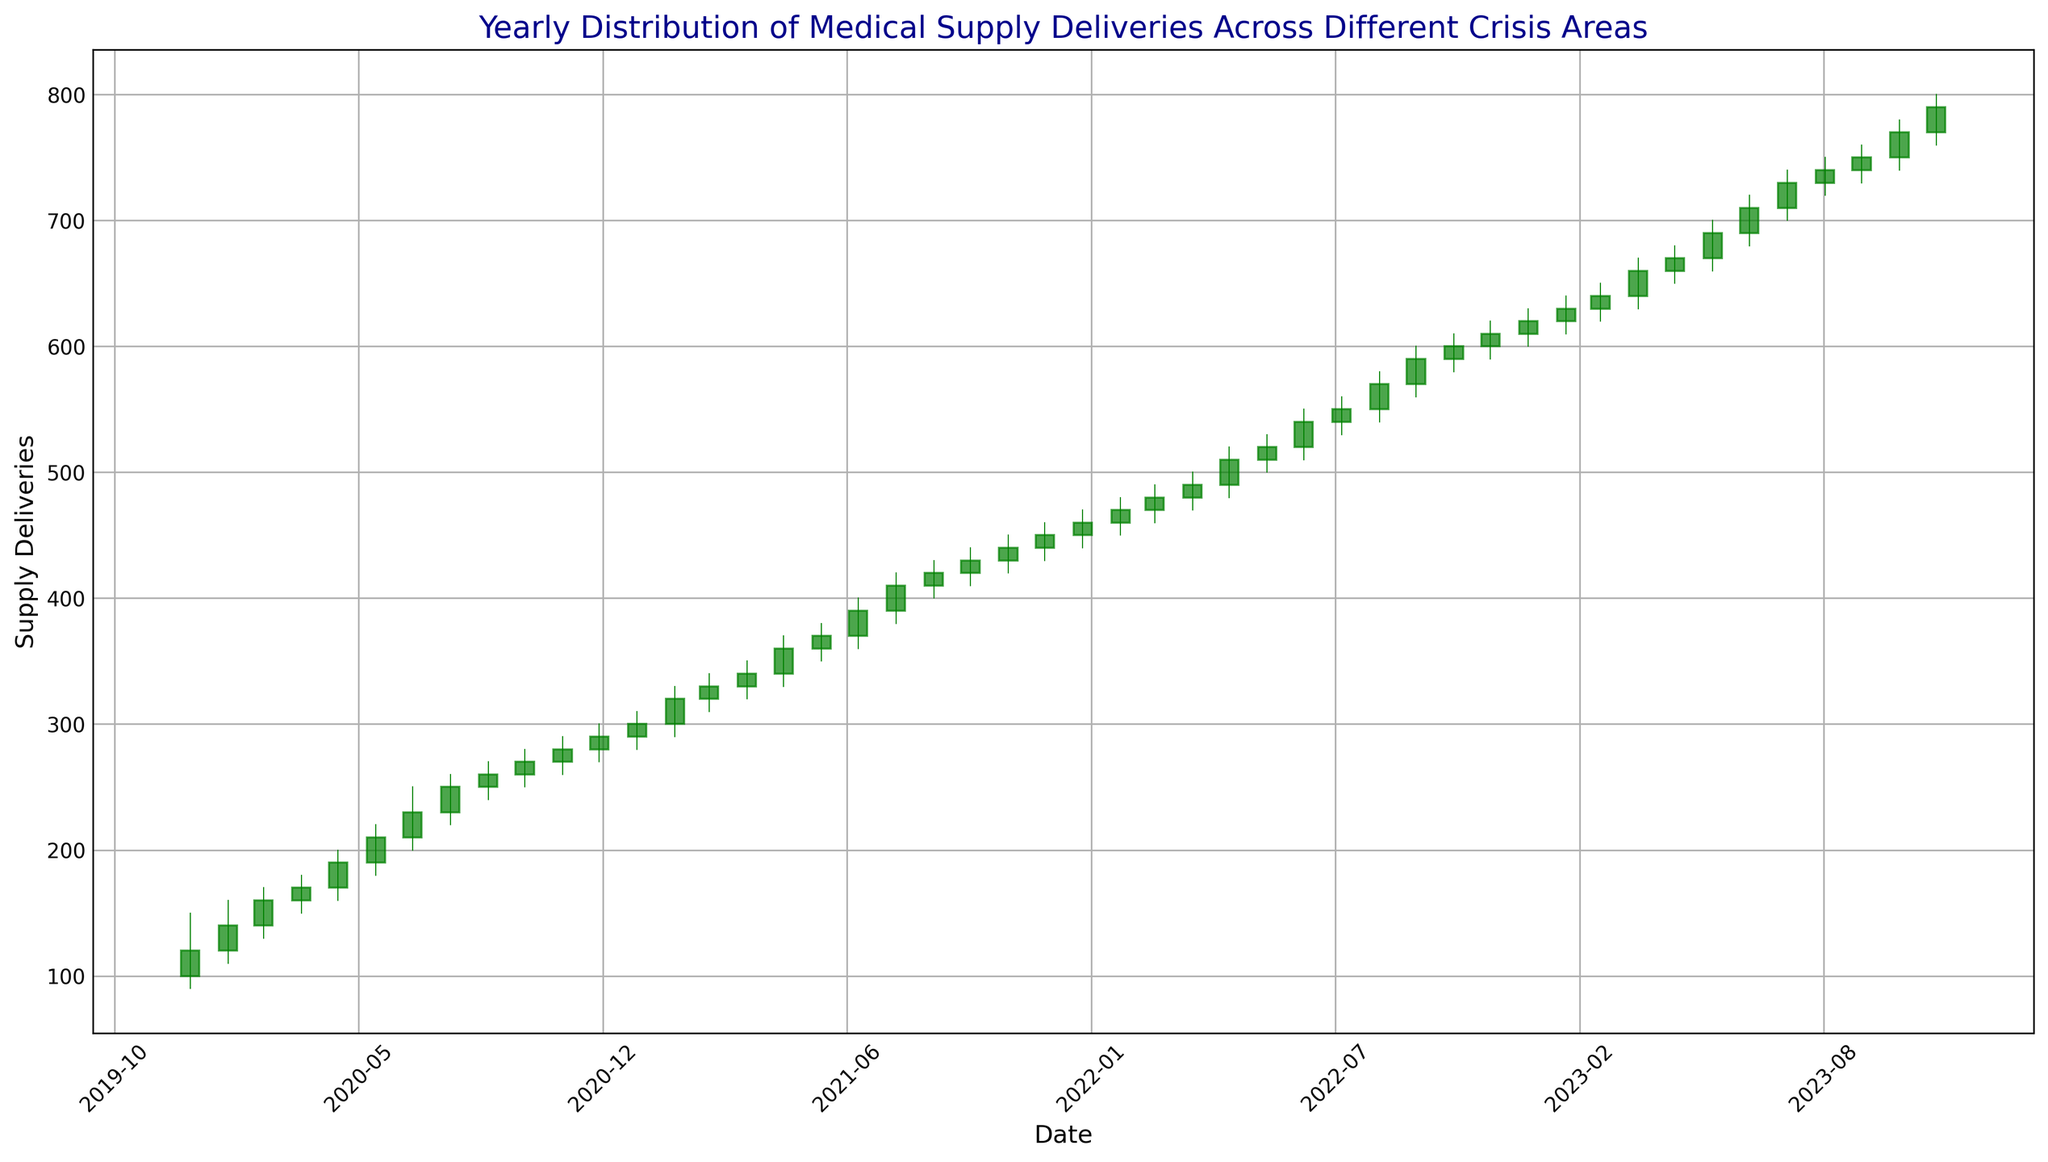What is the general trend in medical supply deliveries over the three-year period? The candlestick chart shows a consistent upward trend, with the closing prices increasing each month over the three-year period.
Answer: Upward trend In which month and year did the highest medical supply delivery volume occur? The highest delivery volume corresponds to the highest "High" value in the chart, which is October 2023 with a high of 780.
Answer: October 2023 Compare the opening value of January 2020 to the closing value of December 2020. Which one is higher? The opening value of January 2020 is 100, and the closing value of December 2020 is 290. Thus, the closing value of December 2020 is higher.
Answer: December 2020 Identify a month where the closing value was lower than the opening value. The figure shows that the red candlesticks represent months where the closing value was lower than the opening value. One such month is January 2020, where the opening value was 100 and the closing value was 120.
Answer: Not applicable (no red candlesticks in data) Calculate the change in medical supply deliveries from May 2020 to May 2021. In May 2020, the closing value was 190, and in May 2021, the closing value was 360. The change is 360 - 190 = 170.
Answer: 170 Which quarter in 2021 had the highest average closing value? To find the highest average closing value, calculate the average for each quarter in 2021: Q1 (Jan-Mar): (300+320+330)/3 = 316.67, Q2 (Apr-Jun): (340+360+370)/3 = 356.67, Q3 (Jul-Sep): (390+410+420)/3 = 406.67, Q4 (Oct-Dec): (430+440+450)/3 = 440. The highest average is in Q4 with 440.
Answer: Q4 2021 Compare the opening value in January 2022 to the closing value in December 2022. Did the medical supply deliveries increase or decrease? The opening value in January 2022 is 450, and the closing value in December 2022 is 610. The deliveries increased.
Answer: Increased What is the average closing value for the entire dataset? To find the average closing value, sum all closing values and divide by the number of months: (120+140+160+170+190+210+230+250+260+270+280+290+300+320+330+340+360+370+390+410+420+430+440+450+460+470+480+490+510+520+540+550+570+590+600+610+620+630+640+660+670+690+710+730+740+750+770+790)/48. This results in 460.
Answer: 460 Identify the month where the medical supply deliveries showed the most significant increase from the previous month. The most significant increase can be found by looking at the largest green candlestick (higher difference between opening and closing). The largest such increase occurs between April 2023 (660) and May 2023 (670).
Answer: May 2023 